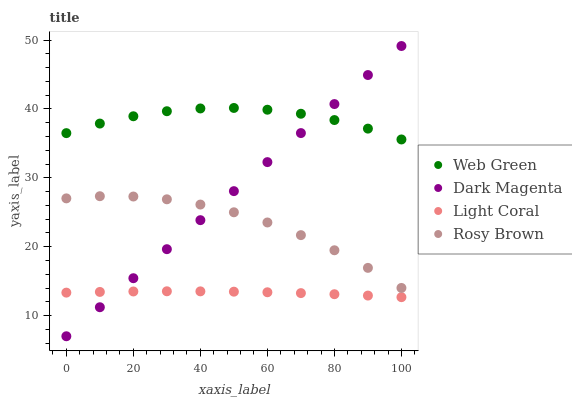Does Light Coral have the minimum area under the curve?
Answer yes or no. Yes. Does Web Green have the maximum area under the curve?
Answer yes or no. Yes. Does Rosy Brown have the minimum area under the curve?
Answer yes or no. No. Does Rosy Brown have the maximum area under the curve?
Answer yes or no. No. Is Dark Magenta the smoothest?
Answer yes or no. Yes. Is Rosy Brown the roughest?
Answer yes or no. Yes. Is Rosy Brown the smoothest?
Answer yes or no. No. Is Dark Magenta the roughest?
Answer yes or no. No. Does Dark Magenta have the lowest value?
Answer yes or no. Yes. Does Rosy Brown have the lowest value?
Answer yes or no. No. Does Dark Magenta have the highest value?
Answer yes or no. Yes. Does Rosy Brown have the highest value?
Answer yes or no. No. Is Light Coral less than Web Green?
Answer yes or no. Yes. Is Web Green greater than Rosy Brown?
Answer yes or no. Yes. Does Rosy Brown intersect Dark Magenta?
Answer yes or no. Yes. Is Rosy Brown less than Dark Magenta?
Answer yes or no. No. Is Rosy Brown greater than Dark Magenta?
Answer yes or no. No. Does Light Coral intersect Web Green?
Answer yes or no. No. 